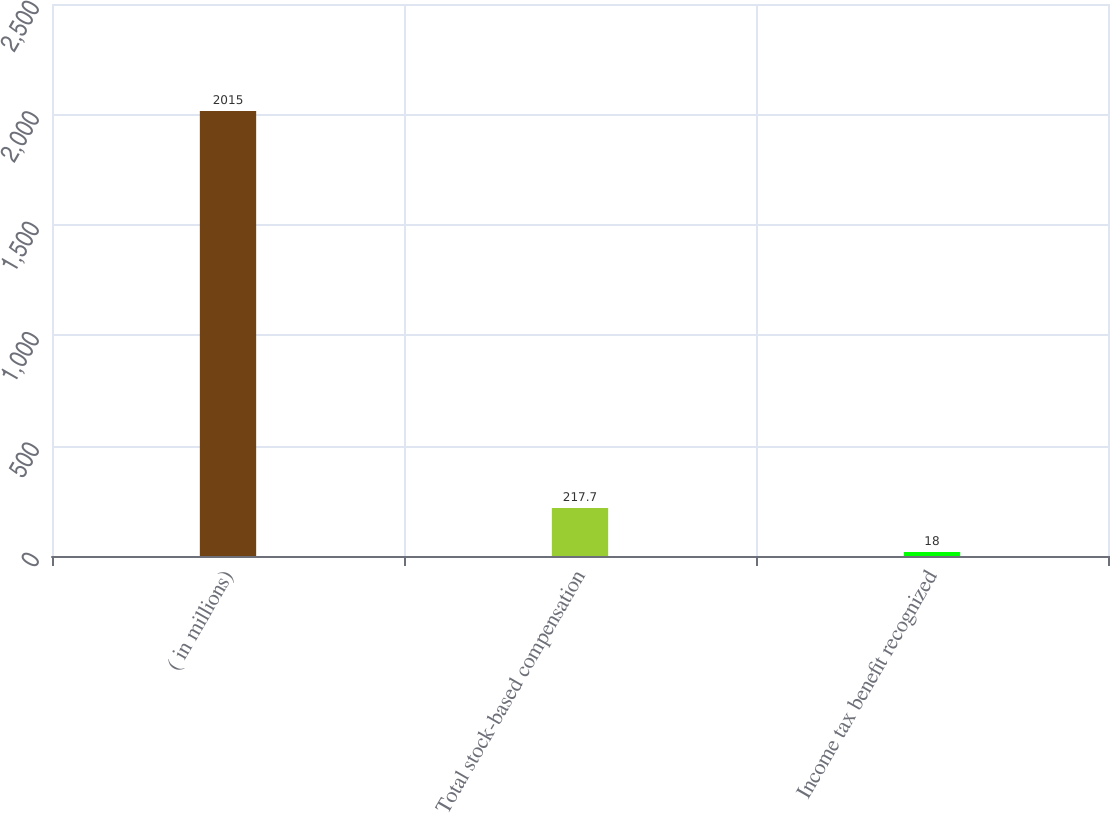Convert chart to OTSL. <chart><loc_0><loc_0><loc_500><loc_500><bar_chart><fcel>( in millions)<fcel>Total stock-based compensation<fcel>Income tax benefit recognized<nl><fcel>2015<fcel>217.7<fcel>18<nl></chart> 